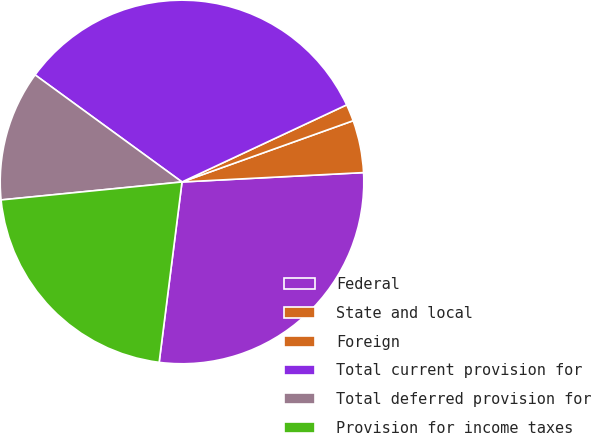Convert chart to OTSL. <chart><loc_0><loc_0><loc_500><loc_500><pie_chart><fcel>Federal<fcel>State and local<fcel>Foreign<fcel>Total current provision for<fcel>Total deferred provision for<fcel>Provision for income taxes<nl><fcel>27.83%<fcel>4.65%<fcel>1.5%<fcel>33.01%<fcel>11.6%<fcel>21.42%<nl></chart> 